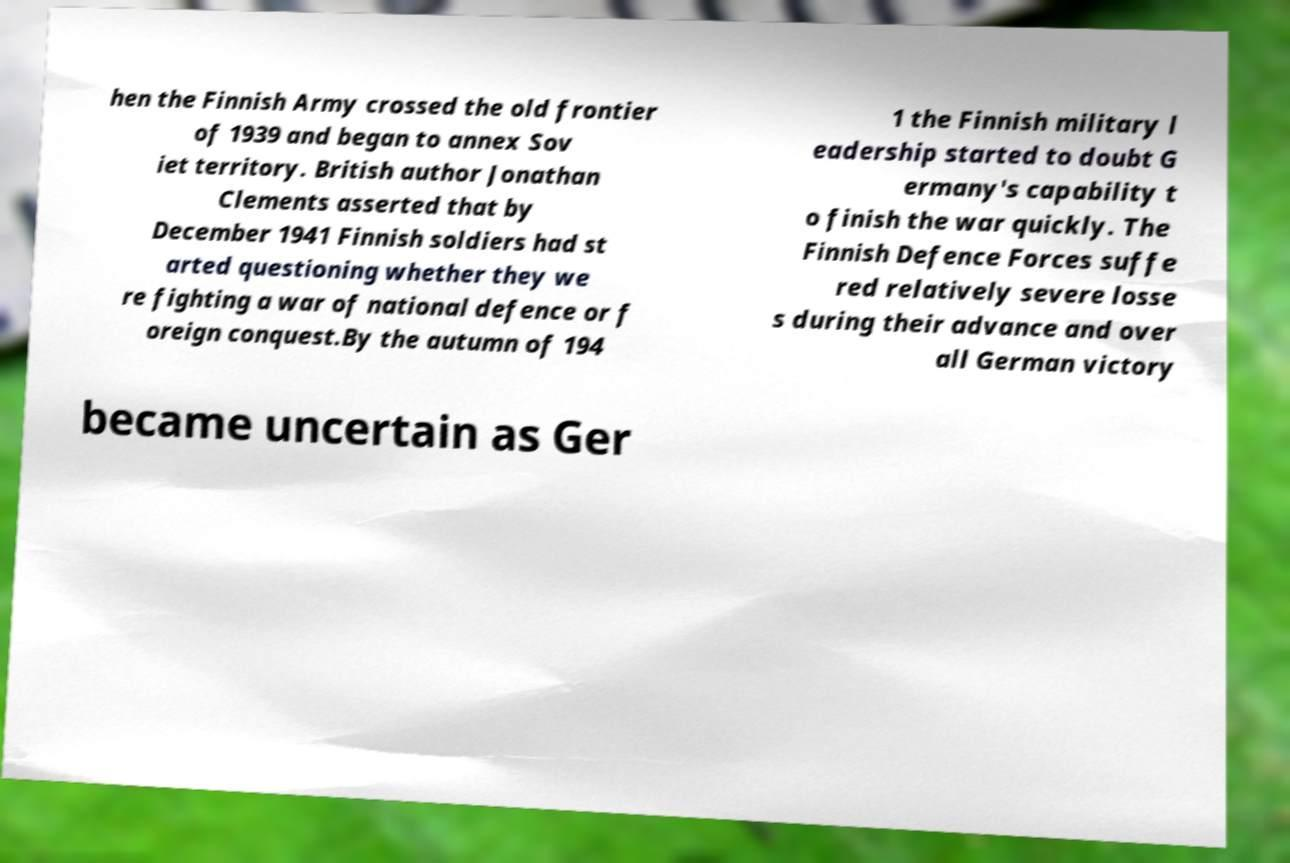Please read and relay the text visible in this image. What does it say? hen the Finnish Army crossed the old frontier of 1939 and began to annex Sov iet territory. British author Jonathan Clements asserted that by December 1941 Finnish soldiers had st arted questioning whether they we re fighting a war of national defence or f oreign conquest.By the autumn of 194 1 the Finnish military l eadership started to doubt G ermany's capability t o finish the war quickly. The Finnish Defence Forces suffe red relatively severe losse s during their advance and over all German victory became uncertain as Ger 